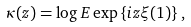Convert formula to latex. <formula><loc_0><loc_0><loc_500><loc_500>\kappa ( z ) = \log E \exp \left \{ i z \xi ( 1 ) \right \} ,</formula> 